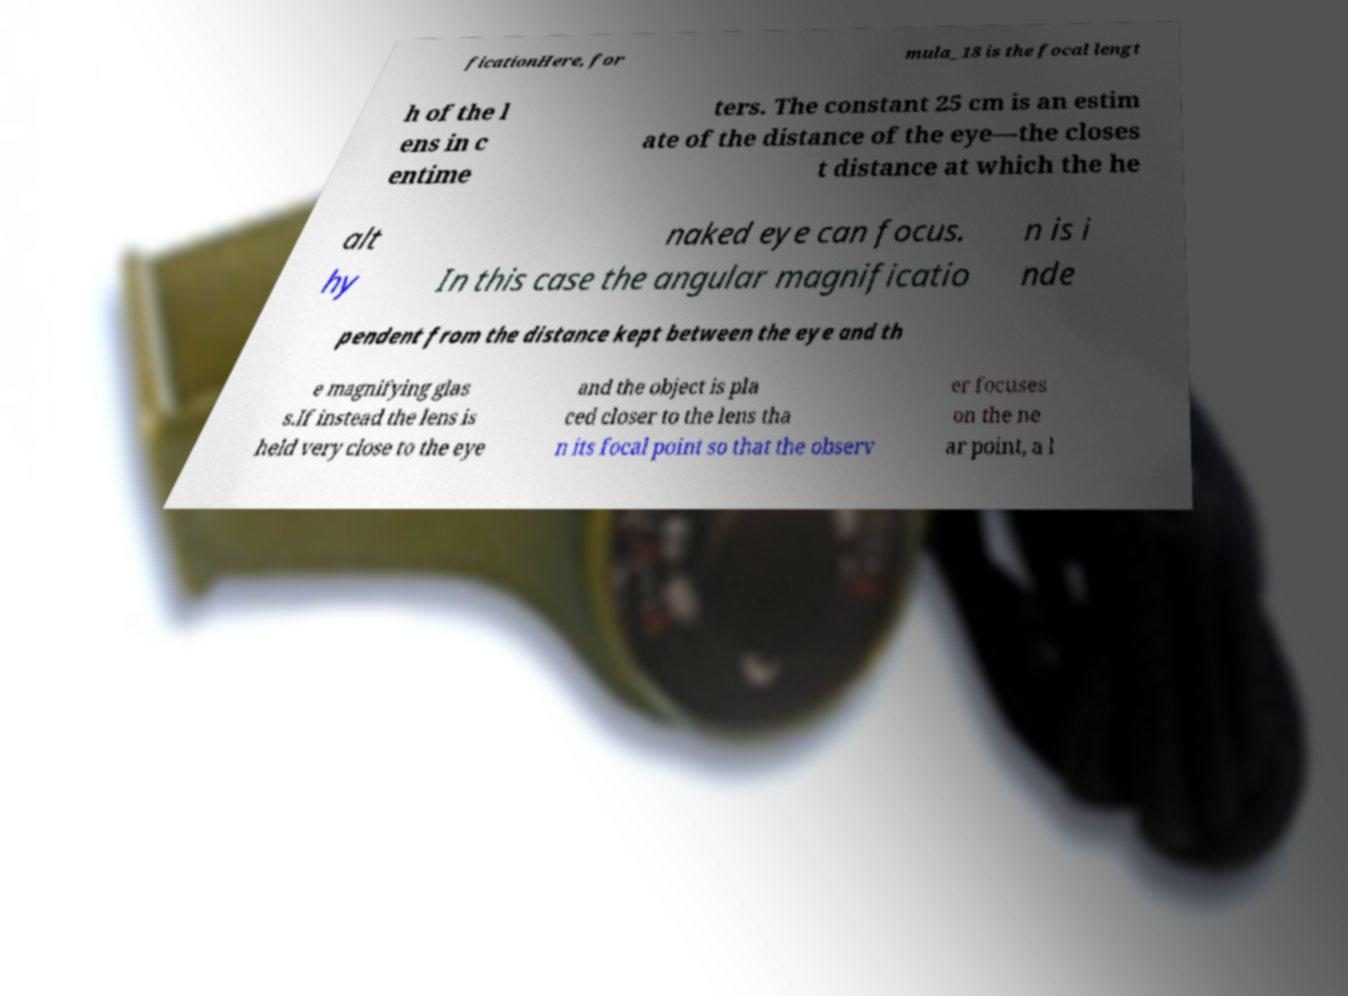Can you read and provide the text displayed in the image?This photo seems to have some interesting text. Can you extract and type it out for me? ficationHere, for mula_18 is the focal lengt h of the l ens in c entime ters. The constant 25 cm is an estim ate of the distance of the eye—the closes t distance at which the he alt hy naked eye can focus. In this case the angular magnificatio n is i nde pendent from the distance kept between the eye and th e magnifying glas s.If instead the lens is held very close to the eye and the object is pla ced closer to the lens tha n its focal point so that the observ er focuses on the ne ar point, a l 